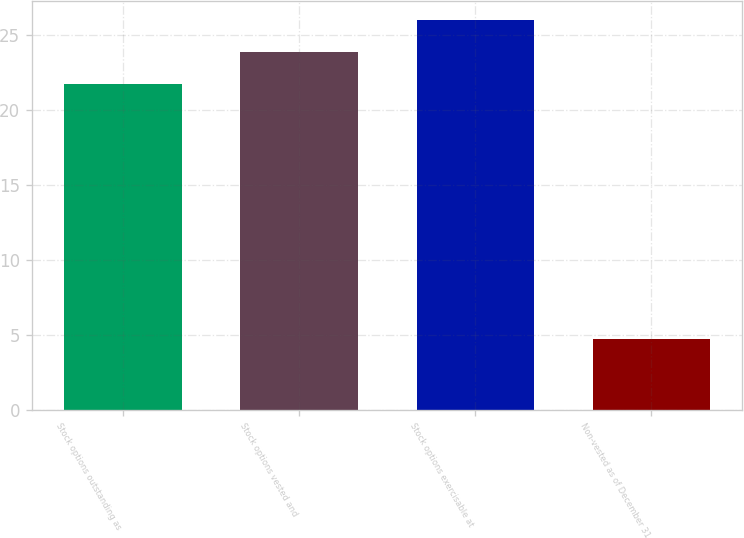<chart> <loc_0><loc_0><loc_500><loc_500><bar_chart><fcel>Stock options outstanding as<fcel>Stock options vested and<fcel>Stock options exercisable at<fcel>Non-vested as of December 31<nl><fcel>21.73<fcel>23.85<fcel>25.97<fcel>4.73<nl></chart> 